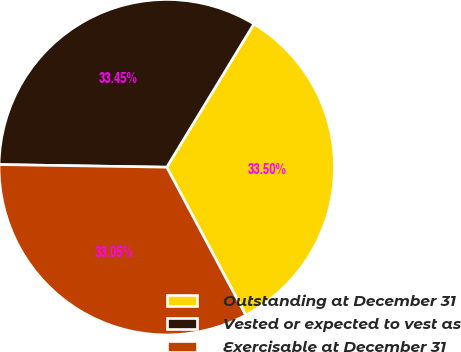Convert chart. <chart><loc_0><loc_0><loc_500><loc_500><pie_chart><fcel>Outstanding at December 31<fcel>Vested or expected to vest as<fcel>Exercisable at December 31<nl><fcel>33.5%<fcel>33.45%<fcel>33.05%<nl></chart> 